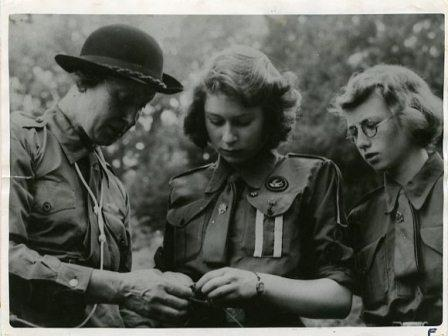What organization is the man's outfit from? scouts 